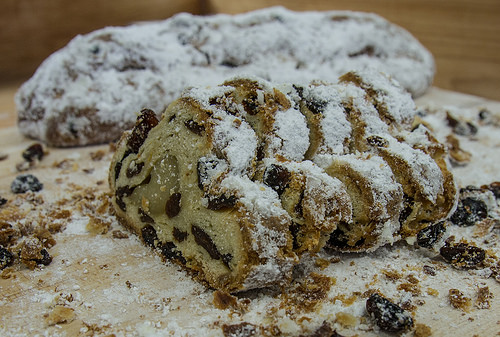<image>
Is there a cake next to the table? No. The cake is not positioned next to the table. They are located in different areas of the scene. 